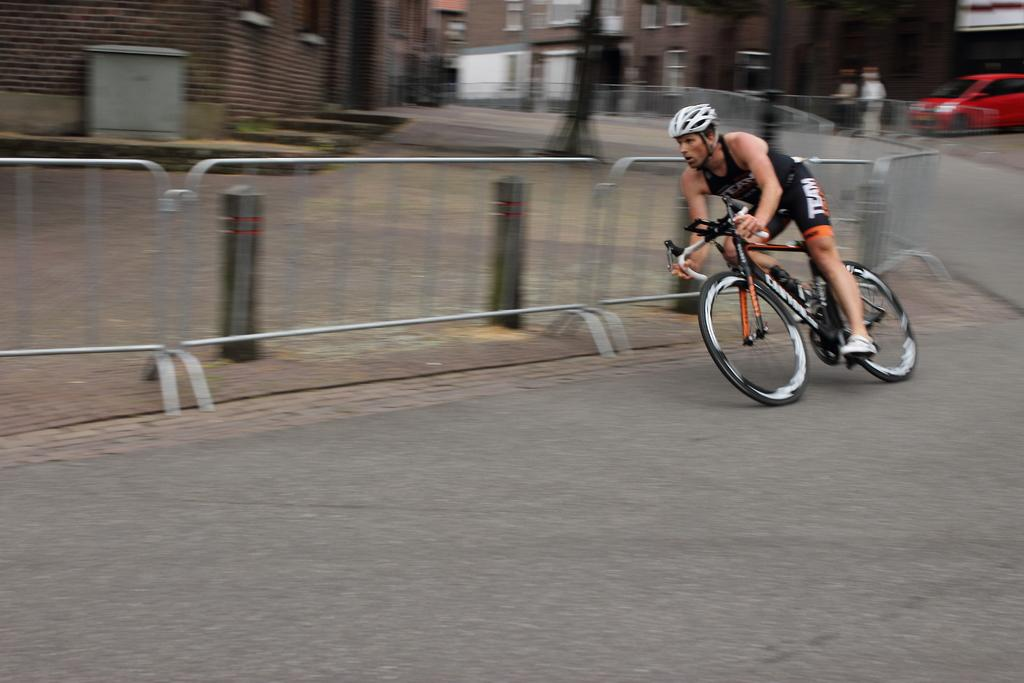What is the man in the image doing? The man is riding a cycle in the image. Where is the man located in the image? The man is on the road in the image. What can be seen in the background of the image? There are buildings, fencing, a car, and two other people in the background of the image. What type of tax does the man pay for riding his cycle in the image? There is no mention of taxes in the image, and the man is not shown paying any taxes for riding his cycle. 